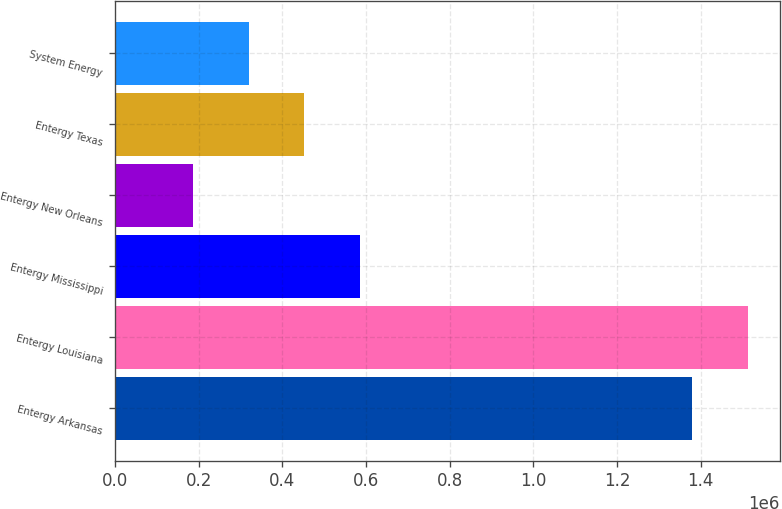<chart> <loc_0><loc_0><loc_500><loc_500><bar_chart><fcel>Entergy Arkansas<fcel>Entergy Louisiana<fcel>Entergy Mississippi<fcel>Entergy New Orleans<fcel>Entergy Texas<fcel>System Energy<nl><fcel>1.37926e+06<fcel>1.51388e+06<fcel>584538<fcel>186247<fcel>451774<fcel>319011<nl></chart> 